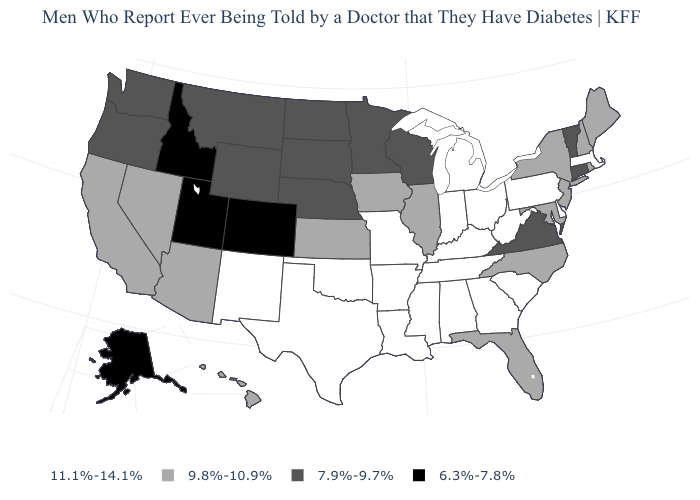What is the value of Texas?
Keep it brief. 11.1%-14.1%. Among the states that border West Virginia , which have the highest value?
Give a very brief answer. Kentucky, Ohio, Pennsylvania. Name the states that have a value in the range 11.1%-14.1%?
Give a very brief answer. Alabama, Arkansas, Delaware, Georgia, Indiana, Kentucky, Louisiana, Massachusetts, Michigan, Mississippi, Missouri, New Mexico, Ohio, Oklahoma, Pennsylvania, South Carolina, Tennessee, Texas, West Virginia. What is the value of Maryland?
Concise answer only. 9.8%-10.9%. Among the states that border Delaware , which have the highest value?
Concise answer only. Pennsylvania. What is the lowest value in the USA?
Give a very brief answer. 6.3%-7.8%. What is the value of Louisiana?
Give a very brief answer. 11.1%-14.1%. What is the value of New York?
Short answer required. 9.8%-10.9%. What is the lowest value in states that border Nevada?
Be succinct. 6.3%-7.8%. What is the value of Nebraska?
Give a very brief answer. 7.9%-9.7%. What is the lowest value in the MidWest?
Write a very short answer. 7.9%-9.7%. Among the states that border North Carolina , which have the lowest value?
Keep it brief. Virginia. Does the first symbol in the legend represent the smallest category?
Quick response, please. No. What is the value of Oklahoma?
Write a very short answer. 11.1%-14.1%. What is the lowest value in the West?
Short answer required. 6.3%-7.8%. 